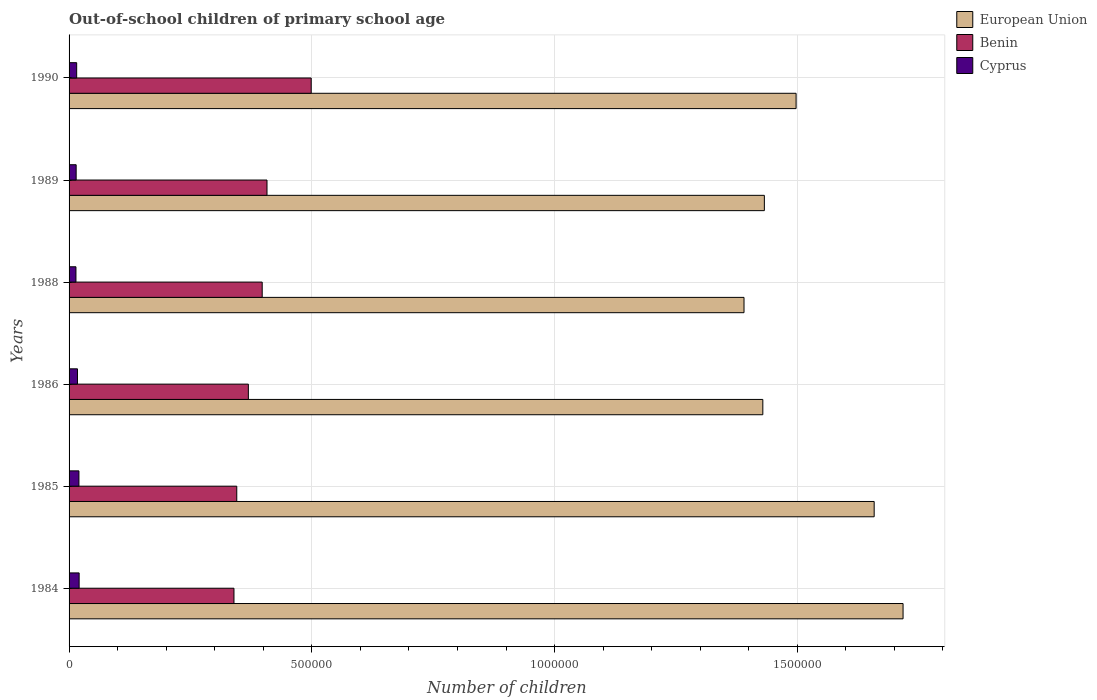How many different coloured bars are there?
Keep it short and to the point. 3. Are the number of bars per tick equal to the number of legend labels?
Your response must be concise. Yes. How many bars are there on the 2nd tick from the bottom?
Provide a succinct answer. 3. What is the number of out-of-school children in Benin in 1986?
Offer a very short reply. 3.69e+05. Across all years, what is the maximum number of out-of-school children in European Union?
Give a very brief answer. 1.72e+06. Across all years, what is the minimum number of out-of-school children in Benin?
Provide a short and direct response. 3.40e+05. In which year was the number of out-of-school children in European Union maximum?
Your answer should be compact. 1984. What is the total number of out-of-school children in Benin in the graph?
Make the answer very short. 2.36e+06. What is the difference between the number of out-of-school children in Benin in 1989 and that in 1990?
Make the answer very short. -9.10e+04. What is the difference between the number of out-of-school children in Cyprus in 1986 and the number of out-of-school children in Benin in 1984?
Your answer should be very brief. -3.22e+05. What is the average number of out-of-school children in European Union per year?
Give a very brief answer. 1.52e+06. In the year 1989, what is the difference between the number of out-of-school children in European Union and number of out-of-school children in Benin?
Give a very brief answer. 1.02e+06. In how many years, is the number of out-of-school children in European Union greater than 1000000 ?
Offer a very short reply. 6. What is the ratio of the number of out-of-school children in European Union in 1984 to that in 1988?
Your response must be concise. 1.24. Is the difference between the number of out-of-school children in European Union in 1984 and 1985 greater than the difference between the number of out-of-school children in Benin in 1984 and 1985?
Provide a short and direct response. Yes. What is the difference between the highest and the second highest number of out-of-school children in Benin?
Offer a very short reply. 9.10e+04. What is the difference between the highest and the lowest number of out-of-school children in Cyprus?
Your answer should be very brief. 6571. In how many years, is the number of out-of-school children in Cyprus greater than the average number of out-of-school children in Cyprus taken over all years?
Make the answer very short. 3. What does the 2nd bar from the top in 1984 represents?
Your answer should be very brief. Benin. What does the 3rd bar from the bottom in 1985 represents?
Provide a short and direct response. Cyprus. Is it the case that in every year, the sum of the number of out-of-school children in Benin and number of out-of-school children in European Union is greater than the number of out-of-school children in Cyprus?
Your response must be concise. Yes. How many years are there in the graph?
Your response must be concise. 6. What is the difference between two consecutive major ticks on the X-axis?
Your response must be concise. 5.00e+05. Are the values on the major ticks of X-axis written in scientific E-notation?
Offer a terse response. No. Does the graph contain any zero values?
Keep it short and to the point. No. How many legend labels are there?
Ensure brevity in your answer.  3. What is the title of the graph?
Ensure brevity in your answer.  Out-of-school children of primary school age. What is the label or title of the X-axis?
Ensure brevity in your answer.  Number of children. What is the Number of children in European Union in 1984?
Offer a very short reply. 1.72e+06. What is the Number of children in Benin in 1984?
Keep it short and to the point. 3.40e+05. What is the Number of children of Cyprus in 1984?
Make the answer very short. 2.08e+04. What is the Number of children in European Union in 1985?
Your answer should be compact. 1.66e+06. What is the Number of children of Benin in 1985?
Your response must be concise. 3.45e+05. What is the Number of children of Cyprus in 1985?
Offer a terse response. 2.03e+04. What is the Number of children in European Union in 1986?
Offer a very short reply. 1.43e+06. What is the Number of children of Benin in 1986?
Offer a terse response. 3.69e+05. What is the Number of children in Cyprus in 1986?
Your answer should be compact. 1.73e+04. What is the Number of children of European Union in 1988?
Ensure brevity in your answer.  1.39e+06. What is the Number of children of Benin in 1988?
Offer a terse response. 3.98e+05. What is the Number of children of Cyprus in 1988?
Offer a very short reply. 1.42e+04. What is the Number of children in European Union in 1989?
Give a very brief answer. 1.43e+06. What is the Number of children in Benin in 1989?
Your answer should be compact. 4.08e+05. What is the Number of children of Cyprus in 1989?
Your response must be concise. 1.46e+04. What is the Number of children of European Union in 1990?
Make the answer very short. 1.50e+06. What is the Number of children of Benin in 1990?
Offer a terse response. 4.99e+05. What is the Number of children of Cyprus in 1990?
Ensure brevity in your answer.  1.56e+04. Across all years, what is the maximum Number of children in European Union?
Provide a succinct answer. 1.72e+06. Across all years, what is the maximum Number of children of Benin?
Your answer should be compact. 4.99e+05. Across all years, what is the maximum Number of children in Cyprus?
Ensure brevity in your answer.  2.08e+04. Across all years, what is the minimum Number of children in European Union?
Keep it short and to the point. 1.39e+06. Across all years, what is the minimum Number of children of Benin?
Your response must be concise. 3.40e+05. Across all years, what is the minimum Number of children in Cyprus?
Offer a terse response. 1.42e+04. What is the total Number of children of European Union in the graph?
Your answer should be very brief. 9.13e+06. What is the total Number of children in Benin in the graph?
Your response must be concise. 2.36e+06. What is the total Number of children in Cyprus in the graph?
Keep it short and to the point. 1.03e+05. What is the difference between the Number of children in European Union in 1984 and that in 1985?
Your answer should be compact. 5.95e+04. What is the difference between the Number of children of Benin in 1984 and that in 1985?
Offer a terse response. -5736. What is the difference between the Number of children in Cyprus in 1984 and that in 1985?
Your response must be concise. 432. What is the difference between the Number of children of European Union in 1984 and that in 1986?
Offer a terse response. 2.89e+05. What is the difference between the Number of children in Benin in 1984 and that in 1986?
Your answer should be compact. -2.96e+04. What is the difference between the Number of children in Cyprus in 1984 and that in 1986?
Ensure brevity in your answer.  3421. What is the difference between the Number of children of European Union in 1984 and that in 1988?
Your answer should be compact. 3.28e+05. What is the difference between the Number of children in Benin in 1984 and that in 1988?
Your response must be concise. -5.81e+04. What is the difference between the Number of children in Cyprus in 1984 and that in 1988?
Your answer should be very brief. 6571. What is the difference between the Number of children of European Union in 1984 and that in 1989?
Your answer should be very brief. 2.86e+05. What is the difference between the Number of children of Benin in 1984 and that in 1989?
Ensure brevity in your answer.  -6.80e+04. What is the difference between the Number of children in Cyprus in 1984 and that in 1989?
Give a very brief answer. 6167. What is the difference between the Number of children of European Union in 1984 and that in 1990?
Keep it short and to the point. 2.20e+05. What is the difference between the Number of children of Benin in 1984 and that in 1990?
Your answer should be compact. -1.59e+05. What is the difference between the Number of children of Cyprus in 1984 and that in 1990?
Ensure brevity in your answer.  5115. What is the difference between the Number of children in European Union in 1985 and that in 1986?
Your response must be concise. 2.29e+05. What is the difference between the Number of children in Benin in 1985 and that in 1986?
Offer a terse response. -2.39e+04. What is the difference between the Number of children of Cyprus in 1985 and that in 1986?
Give a very brief answer. 2989. What is the difference between the Number of children in European Union in 1985 and that in 1988?
Ensure brevity in your answer.  2.68e+05. What is the difference between the Number of children in Benin in 1985 and that in 1988?
Provide a succinct answer. -5.24e+04. What is the difference between the Number of children in Cyprus in 1985 and that in 1988?
Make the answer very short. 6139. What is the difference between the Number of children in European Union in 1985 and that in 1989?
Keep it short and to the point. 2.26e+05. What is the difference between the Number of children of Benin in 1985 and that in 1989?
Ensure brevity in your answer.  -6.23e+04. What is the difference between the Number of children in Cyprus in 1985 and that in 1989?
Provide a succinct answer. 5735. What is the difference between the Number of children of European Union in 1985 and that in 1990?
Your answer should be very brief. 1.61e+05. What is the difference between the Number of children of Benin in 1985 and that in 1990?
Keep it short and to the point. -1.53e+05. What is the difference between the Number of children of Cyprus in 1985 and that in 1990?
Ensure brevity in your answer.  4683. What is the difference between the Number of children of European Union in 1986 and that in 1988?
Ensure brevity in your answer.  3.88e+04. What is the difference between the Number of children of Benin in 1986 and that in 1988?
Give a very brief answer. -2.85e+04. What is the difference between the Number of children of Cyprus in 1986 and that in 1988?
Provide a succinct answer. 3150. What is the difference between the Number of children of European Union in 1986 and that in 1989?
Give a very brief answer. -3133. What is the difference between the Number of children of Benin in 1986 and that in 1989?
Your response must be concise. -3.84e+04. What is the difference between the Number of children in Cyprus in 1986 and that in 1989?
Keep it short and to the point. 2746. What is the difference between the Number of children in European Union in 1986 and that in 1990?
Make the answer very short. -6.85e+04. What is the difference between the Number of children of Benin in 1986 and that in 1990?
Keep it short and to the point. -1.29e+05. What is the difference between the Number of children of Cyprus in 1986 and that in 1990?
Your response must be concise. 1694. What is the difference between the Number of children of European Union in 1988 and that in 1989?
Your answer should be very brief. -4.19e+04. What is the difference between the Number of children of Benin in 1988 and that in 1989?
Your answer should be very brief. -9907. What is the difference between the Number of children in Cyprus in 1988 and that in 1989?
Provide a short and direct response. -404. What is the difference between the Number of children of European Union in 1988 and that in 1990?
Give a very brief answer. -1.07e+05. What is the difference between the Number of children in Benin in 1988 and that in 1990?
Keep it short and to the point. -1.01e+05. What is the difference between the Number of children in Cyprus in 1988 and that in 1990?
Make the answer very short. -1456. What is the difference between the Number of children of European Union in 1989 and that in 1990?
Make the answer very short. -6.54e+04. What is the difference between the Number of children of Benin in 1989 and that in 1990?
Keep it short and to the point. -9.10e+04. What is the difference between the Number of children of Cyprus in 1989 and that in 1990?
Your answer should be compact. -1052. What is the difference between the Number of children in European Union in 1984 and the Number of children in Benin in 1985?
Provide a short and direct response. 1.37e+06. What is the difference between the Number of children of European Union in 1984 and the Number of children of Cyprus in 1985?
Give a very brief answer. 1.70e+06. What is the difference between the Number of children of Benin in 1984 and the Number of children of Cyprus in 1985?
Offer a terse response. 3.19e+05. What is the difference between the Number of children of European Union in 1984 and the Number of children of Benin in 1986?
Make the answer very short. 1.35e+06. What is the difference between the Number of children of European Union in 1984 and the Number of children of Cyprus in 1986?
Your answer should be compact. 1.70e+06. What is the difference between the Number of children in Benin in 1984 and the Number of children in Cyprus in 1986?
Keep it short and to the point. 3.22e+05. What is the difference between the Number of children in European Union in 1984 and the Number of children in Benin in 1988?
Provide a succinct answer. 1.32e+06. What is the difference between the Number of children of European Union in 1984 and the Number of children of Cyprus in 1988?
Your response must be concise. 1.70e+06. What is the difference between the Number of children in Benin in 1984 and the Number of children in Cyprus in 1988?
Keep it short and to the point. 3.25e+05. What is the difference between the Number of children in European Union in 1984 and the Number of children in Benin in 1989?
Your answer should be very brief. 1.31e+06. What is the difference between the Number of children of European Union in 1984 and the Number of children of Cyprus in 1989?
Your answer should be compact. 1.70e+06. What is the difference between the Number of children of Benin in 1984 and the Number of children of Cyprus in 1989?
Give a very brief answer. 3.25e+05. What is the difference between the Number of children in European Union in 1984 and the Number of children in Benin in 1990?
Your answer should be compact. 1.22e+06. What is the difference between the Number of children of European Union in 1984 and the Number of children of Cyprus in 1990?
Offer a very short reply. 1.70e+06. What is the difference between the Number of children of Benin in 1984 and the Number of children of Cyprus in 1990?
Your answer should be very brief. 3.24e+05. What is the difference between the Number of children of European Union in 1985 and the Number of children of Benin in 1986?
Your response must be concise. 1.29e+06. What is the difference between the Number of children of European Union in 1985 and the Number of children of Cyprus in 1986?
Your answer should be very brief. 1.64e+06. What is the difference between the Number of children in Benin in 1985 and the Number of children in Cyprus in 1986?
Provide a short and direct response. 3.28e+05. What is the difference between the Number of children of European Union in 1985 and the Number of children of Benin in 1988?
Make the answer very short. 1.26e+06. What is the difference between the Number of children of European Union in 1985 and the Number of children of Cyprus in 1988?
Provide a short and direct response. 1.64e+06. What is the difference between the Number of children of Benin in 1985 and the Number of children of Cyprus in 1988?
Offer a very short reply. 3.31e+05. What is the difference between the Number of children in European Union in 1985 and the Number of children in Benin in 1989?
Your answer should be compact. 1.25e+06. What is the difference between the Number of children of European Union in 1985 and the Number of children of Cyprus in 1989?
Your response must be concise. 1.64e+06. What is the difference between the Number of children in Benin in 1985 and the Number of children in Cyprus in 1989?
Provide a short and direct response. 3.31e+05. What is the difference between the Number of children of European Union in 1985 and the Number of children of Benin in 1990?
Keep it short and to the point. 1.16e+06. What is the difference between the Number of children in European Union in 1985 and the Number of children in Cyprus in 1990?
Provide a succinct answer. 1.64e+06. What is the difference between the Number of children in Benin in 1985 and the Number of children in Cyprus in 1990?
Offer a very short reply. 3.30e+05. What is the difference between the Number of children in European Union in 1986 and the Number of children in Benin in 1988?
Make the answer very short. 1.03e+06. What is the difference between the Number of children of European Union in 1986 and the Number of children of Cyprus in 1988?
Offer a terse response. 1.41e+06. What is the difference between the Number of children in Benin in 1986 and the Number of children in Cyprus in 1988?
Make the answer very short. 3.55e+05. What is the difference between the Number of children in European Union in 1986 and the Number of children in Benin in 1989?
Provide a short and direct response. 1.02e+06. What is the difference between the Number of children of European Union in 1986 and the Number of children of Cyprus in 1989?
Keep it short and to the point. 1.41e+06. What is the difference between the Number of children in Benin in 1986 and the Number of children in Cyprus in 1989?
Keep it short and to the point. 3.55e+05. What is the difference between the Number of children in European Union in 1986 and the Number of children in Benin in 1990?
Provide a succinct answer. 9.30e+05. What is the difference between the Number of children of European Union in 1986 and the Number of children of Cyprus in 1990?
Keep it short and to the point. 1.41e+06. What is the difference between the Number of children of Benin in 1986 and the Number of children of Cyprus in 1990?
Keep it short and to the point. 3.54e+05. What is the difference between the Number of children in European Union in 1988 and the Number of children in Benin in 1989?
Keep it short and to the point. 9.83e+05. What is the difference between the Number of children of European Union in 1988 and the Number of children of Cyprus in 1989?
Offer a very short reply. 1.38e+06. What is the difference between the Number of children in Benin in 1988 and the Number of children in Cyprus in 1989?
Offer a terse response. 3.83e+05. What is the difference between the Number of children in European Union in 1988 and the Number of children in Benin in 1990?
Keep it short and to the point. 8.92e+05. What is the difference between the Number of children of European Union in 1988 and the Number of children of Cyprus in 1990?
Keep it short and to the point. 1.37e+06. What is the difference between the Number of children in Benin in 1988 and the Number of children in Cyprus in 1990?
Make the answer very short. 3.82e+05. What is the difference between the Number of children in European Union in 1989 and the Number of children in Benin in 1990?
Your response must be concise. 9.33e+05. What is the difference between the Number of children in European Union in 1989 and the Number of children in Cyprus in 1990?
Provide a succinct answer. 1.42e+06. What is the difference between the Number of children of Benin in 1989 and the Number of children of Cyprus in 1990?
Your answer should be compact. 3.92e+05. What is the average Number of children in European Union per year?
Give a very brief answer. 1.52e+06. What is the average Number of children in Benin per year?
Give a very brief answer. 3.93e+05. What is the average Number of children in Cyprus per year?
Make the answer very short. 1.71e+04. In the year 1984, what is the difference between the Number of children in European Union and Number of children in Benin?
Provide a succinct answer. 1.38e+06. In the year 1984, what is the difference between the Number of children in European Union and Number of children in Cyprus?
Your response must be concise. 1.70e+06. In the year 1984, what is the difference between the Number of children in Benin and Number of children in Cyprus?
Keep it short and to the point. 3.19e+05. In the year 1985, what is the difference between the Number of children of European Union and Number of children of Benin?
Your answer should be very brief. 1.31e+06. In the year 1985, what is the difference between the Number of children in European Union and Number of children in Cyprus?
Your answer should be compact. 1.64e+06. In the year 1985, what is the difference between the Number of children of Benin and Number of children of Cyprus?
Ensure brevity in your answer.  3.25e+05. In the year 1986, what is the difference between the Number of children in European Union and Number of children in Benin?
Provide a succinct answer. 1.06e+06. In the year 1986, what is the difference between the Number of children in European Union and Number of children in Cyprus?
Ensure brevity in your answer.  1.41e+06. In the year 1986, what is the difference between the Number of children in Benin and Number of children in Cyprus?
Provide a succinct answer. 3.52e+05. In the year 1988, what is the difference between the Number of children in European Union and Number of children in Benin?
Ensure brevity in your answer.  9.92e+05. In the year 1988, what is the difference between the Number of children of European Union and Number of children of Cyprus?
Provide a short and direct response. 1.38e+06. In the year 1988, what is the difference between the Number of children in Benin and Number of children in Cyprus?
Your answer should be very brief. 3.84e+05. In the year 1989, what is the difference between the Number of children in European Union and Number of children in Benin?
Make the answer very short. 1.02e+06. In the year 1989, what is the difference between the Number of children of European Union and Number of children of Cyprus?
Ensure brevity in your answer.  1.42e+06. In the year 1989, what is the difference between the Number of children in Benin and Number of children in Cyprus?
Your answer should be compact. 3.93e+05. In the year 1990, what is the difference between the Number of children in European Union and Number of children in Benin?
Your answer should be compact. 9.99e+05. In the year 1990, what is the difference between the Number of children of European Union and Number of children of Cyprus?
Provide a short and direct response. 1.48e+06. In the year 1990, what is the difference between the Number of children in Benin and Number of children in Cyprus?
Your answer should be very brief. 4.83e+05. What is the ratio of the Number of children of European Union in 1984 to that in 1985?
Make the answer very short. 1.04. What is the ratio of the Number of children of Benin in 1984 to that in 1985?
Make the answer very short. 0.98. What is the ratio of the Number of children of Cyprus in 1984 to that in 1985?
Your answer should be compact. 1.02. What is the ratio of the Number of children of European Union in 1984 to that in 1986?
Provide a succinct answer. 1.2. What is the ratio of the Number of children of Benin in 1984 to that in 1986?
Offer a very short reply. 0.92. What is the ratio of the Number of children in Cyprus in 1984 to that in 1986?
Your answer should be very brief. 1.2. What is the ratio of the Number of children in European Union in 1984 to that in 1988?
Offer a very short reply. 1.24. What is the ratio of the Number of children of Benin in 1984 to that in 1988?
Provide a short and direct response. 0.85. What is the ratio of the Number of children of Cyprus in 1984 to that in 1988?
Make the answer very short. 1.46. What is the ratio of the Number of children in European Union in 1984 to that in 1989?
Ensure brevity in your answer.  1.2. What is the ratio of the Number of children in Benin in 1984 to that in 1989?
Make the answer very short. 0.83. What is the ratio of the Number of children of Cyprus in 1984 to that in 1989?
Ensure brevity in your answer.  1.42. What is the ratio of the Number of children of European Union in 1984 to that in 1990?
Your answer should be compact. 1.15. What is the ratio of the Number of children in Benin in 1984 to that in 1990?
Ensure brevity in your answer.  0.68. What is the ratio of the Number of children of Cyprus in 1984 to that in 1990?
Your answer should be very brief. 1.33. What is the ratio of the Number of children in European Union in 1985 to that in 1986?
Your answer should be very brief. 1.16. What is the ratio of the Number of children in Benin in 1985 to that in 1986?
Keep it short and to the point. 0.94. What is the ratio of the Number of children of Cyprus in 1985 to that in 1986?
Ensure brevity in your answer.  1.17. What is the ratio of the Number of children of European Union in 1985 to that in 1988?
Offer a very short reply. 1.19. What is the ratio of the Number of children of Benin in 1985 to that in 1988?
Provide a short and direct response. 0.87. What is the ratio of the Number of children in Cyprus in 1985 to that in 1988?
Your response must be concise. 1.43. What is the ratio of the Number of children of European Union in 1985 to that in 1989?
Your answer should be very brief. 1.16. What is the ratio of the Number of children of Benin in 1985 to that in 1989?
Provide a short and direct response. 0.85. What is the ratio of the Number of children in Cyprus in 1985 to that in 1989?
Provide a short and direct response. 1.39. What is the ratio of the Number of children in European Union in 1985 to that in 1990?
Ensure brevity in your answer.  1.11. What is the ratio of the Number of children of Benin in 1985 to that in 1990?
Give a very brief answer. 0.69. What is the ratio of the Number of children of Cyprus in 1985 to that in 1990?
Provide a short and direct response. 1.3. What is the ratio of the Number of children of European Union in 1986 to that in 1988?
Offer a very short reply. 1.03. What is the ratio of the Number of children of Benin in 1986 to that in 1988?
Your answer should be compact. 0.93. What is the ratio of the Number of children in Cyprus in 1986 to that in 1988?
Ensure brevity in your answer.  1.22. What is the ratio of the Number of children in Benin in 1986 to that in 1989?
Provide a short and direct response. 0.91. What is the ratio of the Number of children in Cyprus in 1986 to that in 1989?
Give a very brief answer. 1.19. What is the ratio of the Number of children of European Union in 1986 to that in 1990?
Your response must be concise. 0.95. What is the ratio of the Number of children in Benin in 1986 to that in 1990?
Your answer should be very brief. 0.74. What is the ratio of the Number of children of Cyprus in 1986 to that in 1990?
Offer a very short reply. 1.11. What is the ratio of the Number of children of European Union in 1988 to that in 1989?
Offer a terse response. 0.97. What is the ratio of the Number of children in Benin in 1988 to that in 1989?
Give a very brief answer. 0.98. What is the ratio of the Number of children in Cyprus in 1988 to that in 1989?
Keep it short and to the point. 0.97. What is the ratio of the Number of children of European Union in 1988 to that in 1990?
Give a very brief answer. 0.93. What is the ratio of the Number of children of Benin in 1988 to that in 1990?
Your answer should be very brief. 0.8. What is the ratio of the Number of children of Cyprus in 1988 to that in 1990?
Keep it short and to the point. 0.91. What is the ratio of the Number of children in European Union in 1989 to that in 1990?
Provide a succinct answer. 0.96. What is the ratio of the Number of children in Benin in 1989 to that in 1990?
Keep it short and to the point. 0.82. What is the ratio of the Number of children of Cyprus in 1989 to that in 1990?
Provide a short and direct response. 0.93. What is the difference between the highest and the second highest Number of children in European Union?
Provide a short and direct response. 5.95e+04. What is the difference between the highest and the second highest Number of children in Benin?
Offer a very short reply. 9.10e+04. What is the difference between the highest and the second highest Number of children of Cyprus?
Offer a terse response. 432. What is the difference between the highest and the lowest Number of children of European Union?
Make the answer very short. 3.28e+05. What is the difference between the highest and the lowest Number of children of Benin?
Offer a terse response. 1.59e+05. What is the difference between the highest and the lowest Number of children in Cyprus?
Offer a very short reply. 6571. 